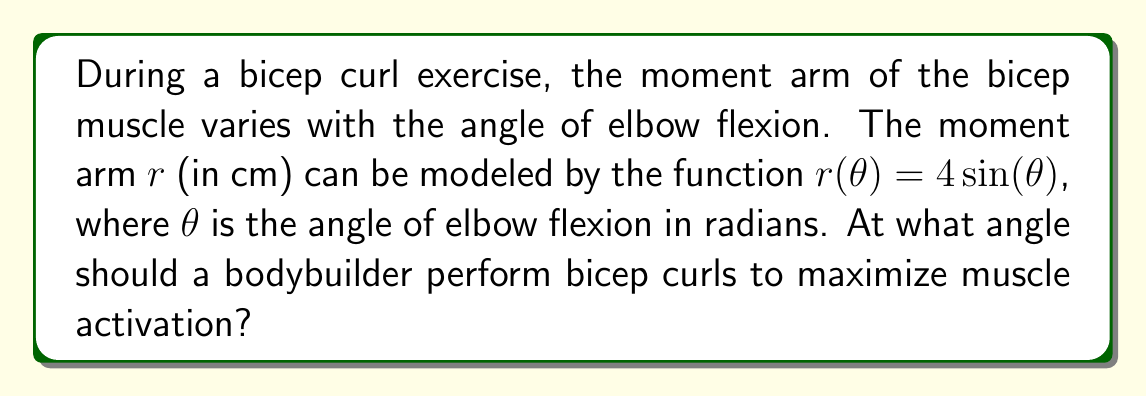Give your solution to this math problem. To find the angle that maximizes muscle activation, we need to determine the angle at which the moment arm is greatest. This is because a larger moment arm results in greater torque and, consequently, higher muscle activation.

Steps to solve:

1) The moment arm is given by the function $r(\theta) = 4\sin(\theta)$.

2) To find the maximum value of this function, we need to find where its derivative equals zero:

   $$\frac{dr}{d\theta} = 4\cos(\theta)$$

3) Set this equal to zero:

   $$4\cos(\theta) = 0$$

4) Solve for $\theta$:

   $$\cos(\theta) = 0$$
   $$\theta = \frac{\pi}{2}$$ or $$\frac{3\pi}{2}$$

5) Since we're dealing with elbow flexion, we're only interested in the solution in the first quadrant, which is $\frac{\pi}{2}$.

6) To confirm this is a maximum (not a minimum), we can check the second derivative:

   $$\frac{d^2r}{d\theta^2} = -4\sin(\theta)$$

   At $\theta = \frac{\pi}{2}$, this is negative, confirming a maximum.

7) Convert radians to degrees:

   $$\frac{\pi}{2} \text{ radians} = 90^\circ$$

Therefore, the bicep curl should be performed at a 90° angle of elbow flexion to maximize muscle activation.
Answer: 90° 